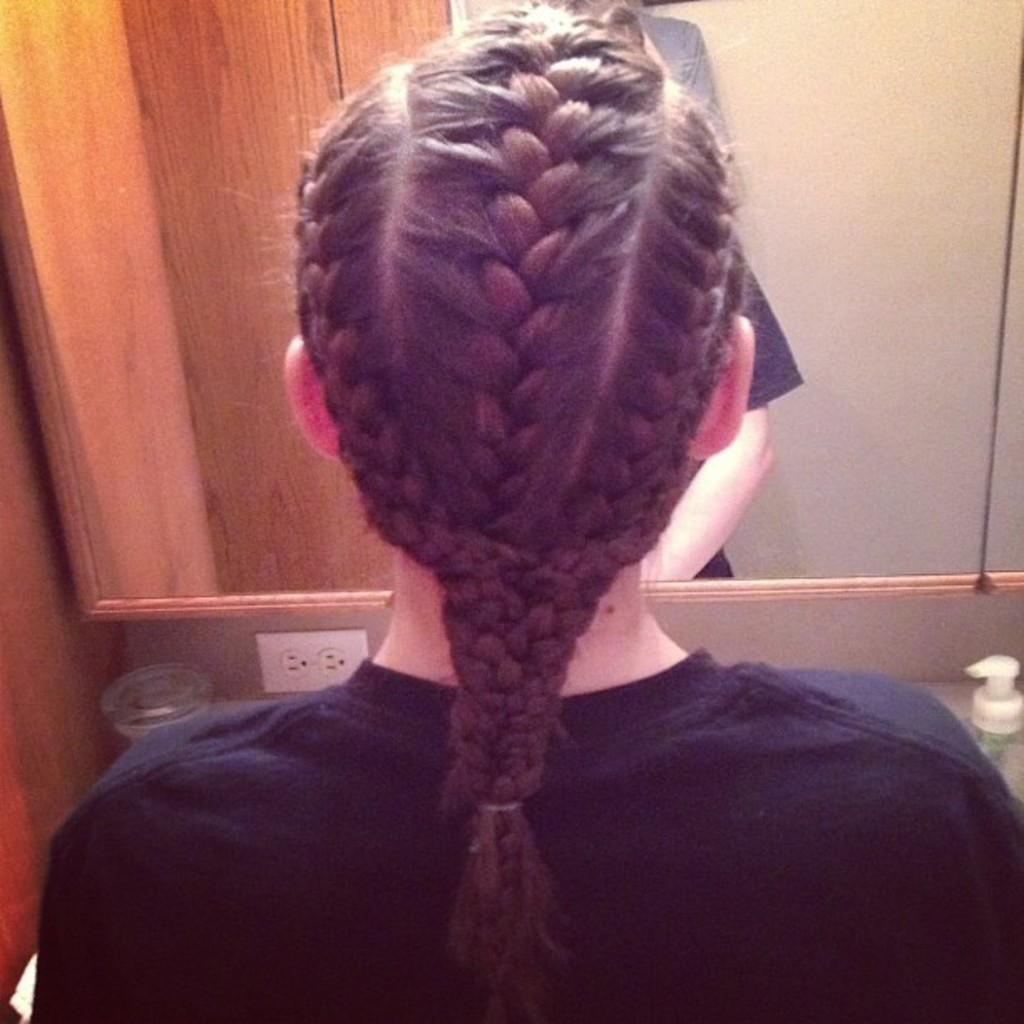Who is the main subject in the image? There is a girl in the image. Can you describe the girl's hairstyle? The girl has a braid in the middle. What object is present in front of the girl? There is a mirror in front of the girl. What type of dinner is the girl preparing in the image? There is no indication of dinner preparation in the image; it only shows the girl with a braid and a mirror in front of her. 